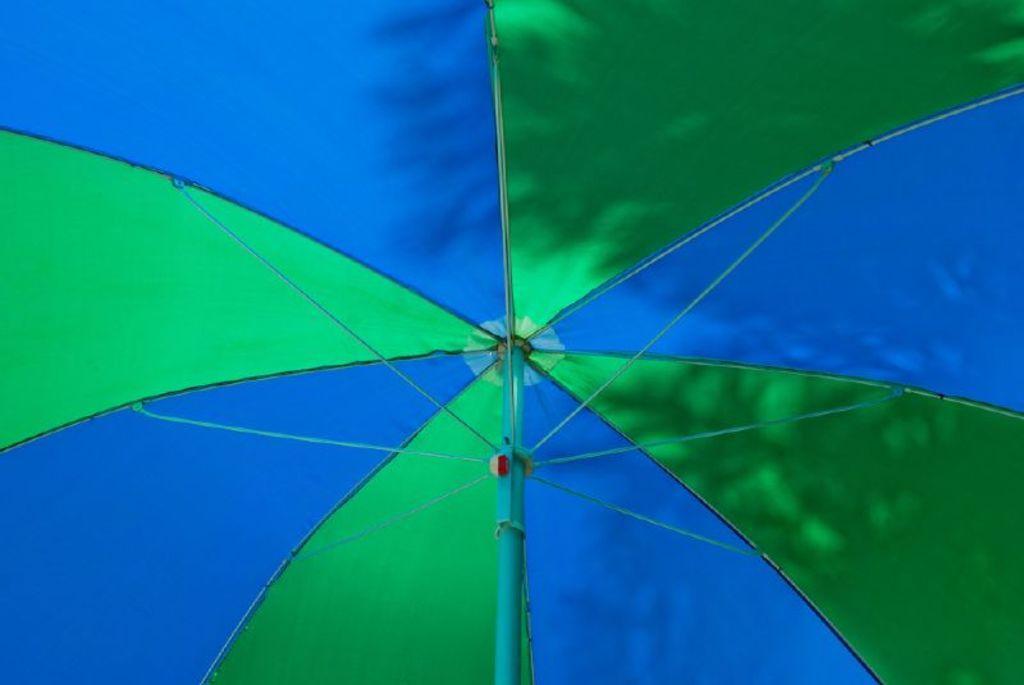Please provide a concise description of this image. In this picture there is an umbrella in blue and in green color and there is a shadow of a tree on the umbrella. 